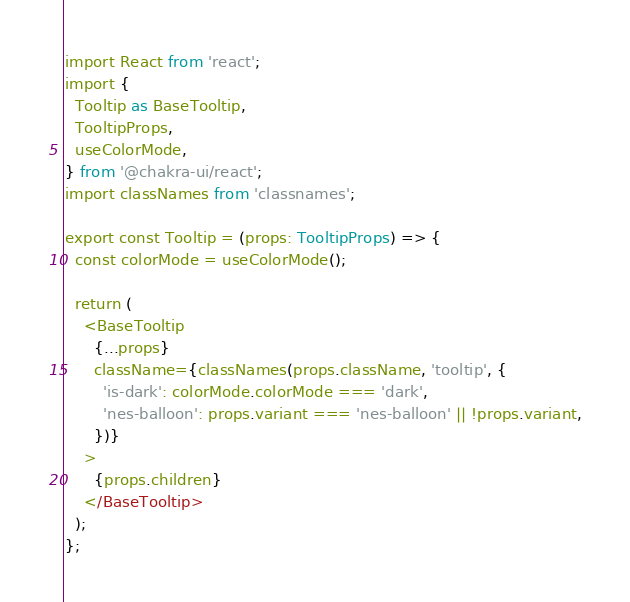<code> <loc_0><loc_0><loc_500><loc_500><_TypeScript_>import React from 'react';
import {
  Tooltip as BaseTooltip,
  TooltipProps,
  useColorMode,
} from '@chakra-ui/react';
import classNames from 'classnames';

export const Tooltip = (props: TooltipProps) => {
  const colorMode = useColorMode();

  return (
    <BaseTooltip
      {...props}
      className={classNames(props.className, 'tooltip', {
        'is-dark': colorMode.colorMode === 'dark',
        'nes-balloon': props.variant === 'nes-balloon' || !props.variant,
      })}
    >
      {props.children}
    </BaseTooltip>
  );
};
</code> 